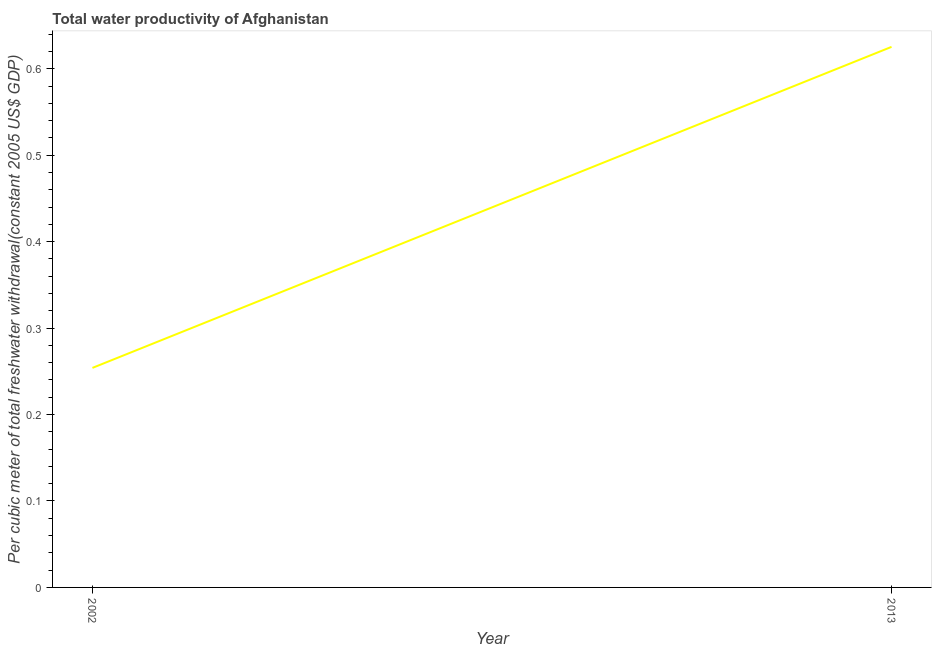What is the total water productivity in 2002?
Offer a terse response. 0.25. Across all years, what is the maximum total water productivity?
Keep it short and to the point. 0.63. Across all years, what is the minimum total water productivity?
Your response must be concise. 0.25. In which year was the total water productivity maximum?
Provide a short and direct response. 2013. In which year was the total water productivity minimum?
Provide a succinct answer. 2002. What is the sum of the total water productivity?
Your answer should be compact. 0.88. What is the difference between the total water productivity in 2002 and 2013?
Offer a terse response. -0.37. What is the average total water productivity per year?
Your response must be concise. 0.44. What is the median total water productivity?
Offer a terse response. 0.44. In how many years, is the total water productivity greater than 0.30000000000000004 US$?
Keep it short and to the point. 1. Do a majority of the years between 2013 and 2002 (inclusive) have total water productivity greater than 0.38000000000000006 US$?
Your response must be concise. No. What is the ratio of the total water productivity in 2002 to that in 2013?
Offer a terse response. 0.41. How many lines are there?
Keep it short and to the point. 1. Are the values on the major ticks of Y-axis written in scientific E-notation?
Offer a terse response. No. Does the graph contain any zero values?
Provide a succinct answer. No. Does the graph contain grids?
Provide a short and direct response. No. What is the title of the graph?
Ensure brevity in your answer.  Total water productivity of Afghanistan. What is the label or title of the X-axis?
Make the answer very short. Year. What is the label or title of the Y-axis?
Provide a succinct answer. Per cubic meter of total freshwater withdrawal(constant 2005 US$ GDP). What is the Per cubic meter of total freshwater withdrawal(constant 2005 US$ GDP) of 2002?
Provide a succinct answer. 0.25. What is the Per cubic meter of total freshwater withdrawal(constant 2005 US$ GDP) in 2013?
Your answer should be very brief. 0.63. What is the difference between the Per cubic meter of total freshwater withdrawal(constant 2005 US$ GDP) in 2002 and 2013?
Your response must be concise. -0.37. What is the ratio of the Per cubic meter of total freshwater withdrawal(constant 2005 US$ GDP) in 2002 to that in 2013?
Your response must be concise. 0.41. 